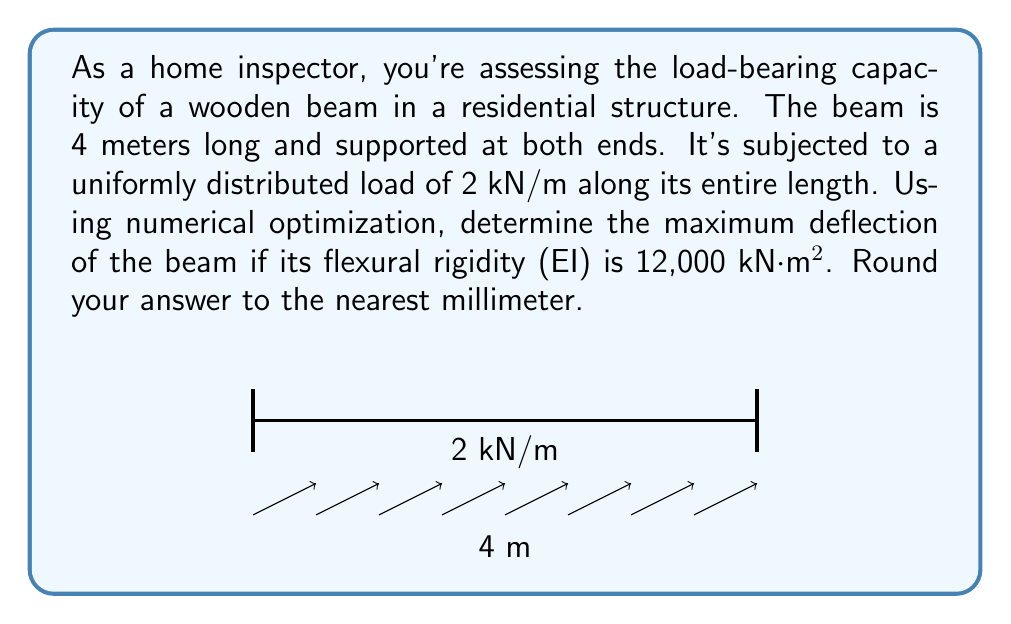Could you help me with this problem? To solve this problem, we'll use the principle of virtual work and apply numerical optimization techniques. Here's a step-by-step approach:

1) For a simply supported beam with uniformly distributed load, the deflection curve is given by:

   $$y(x) = \frac{wx}{24EI}(L^3 - 2Lx^2 + x^3)$$

   where $w$ is the distributed load, $L$ is the beam length, $E$ is the elastic modulus, and $I$ is the moment of inertia.

2) We need to find the maximum deflection, which occurs at the midspan ($x = L/2$). Substituting this into the equation:

   $$y_{max} = \frac{5wL^4}{384EI}$$

3) Now, let's plug in our known values:
   $w = 2$ kN/m
   $L = 4$ m
   $EI = 12,000$ kN⋅m²

4) Solving:

   $$y_{max} = \frac{5 \cdot 2 \cdot 4^4}{384 \cdot 12,000} = \frac{5 \cdot 2 \cdot 256}{384 \cdot 12,000} = \frac{2560}{4,608,000} = 0.000555556$$

5) Converting to millimeters:

   $$y_{max} = 0.000555556 \cdot 1000 = 0.555556$$ mm

6) Rounding to the nearest millimeter:

   $$y_{max} \approx 1$$ mm
Answer: 1 mm 